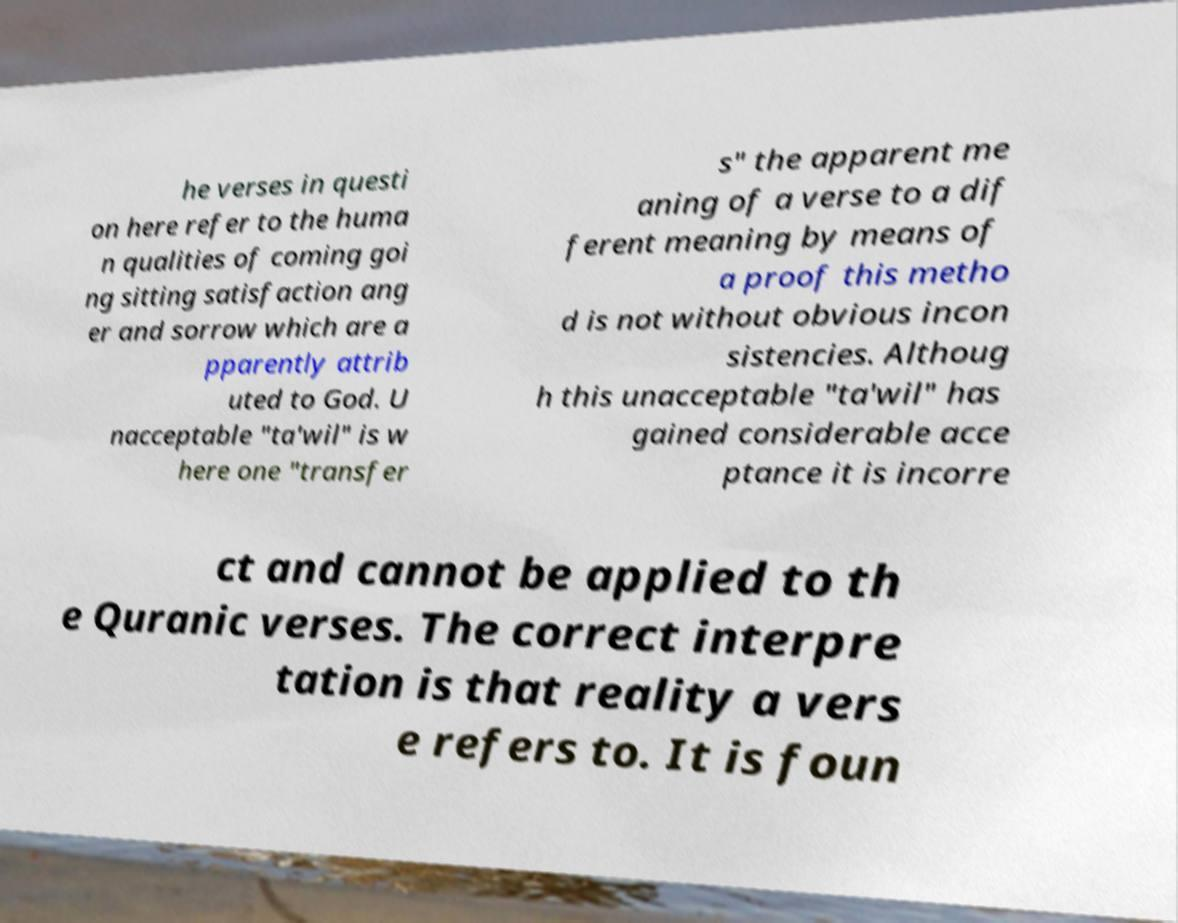Could you assist in decoding the text presented in this image and type it out clearly? he verses in questi on here refer to the huma n qualities of coming goi ng sitting satisfaction ang er and sorrow which are a pparently attrib uted to God. U nacceptable "ta'wil" is w here one "transfer s" the apparent me aning of a verse to a dif ferent meaning by means of a proof this metho d is not without obvious incon sistencies. Althoug h this unacceptable "ta'wil" has gained considerable acce ptance it is incorre ct and cannot be applied to th e Quranic verses. The correct interpre tation is that reality a vers e refers to. It is foun 